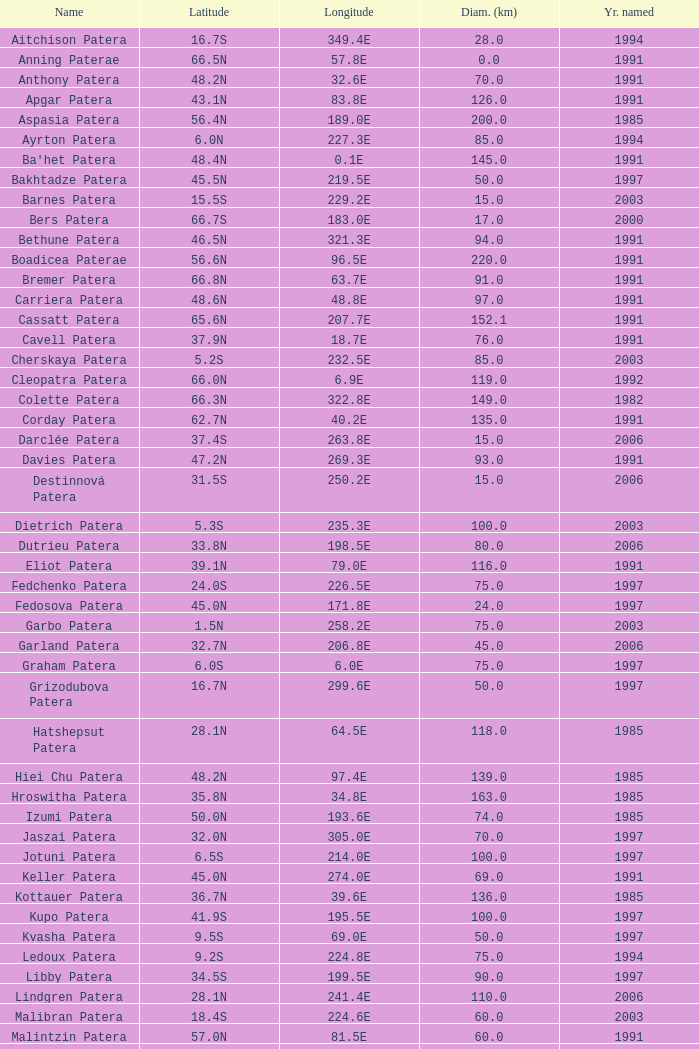What is the average Year Named, when Latitude is 37.9N, and when Diameter (km) is greater than 76? None. 